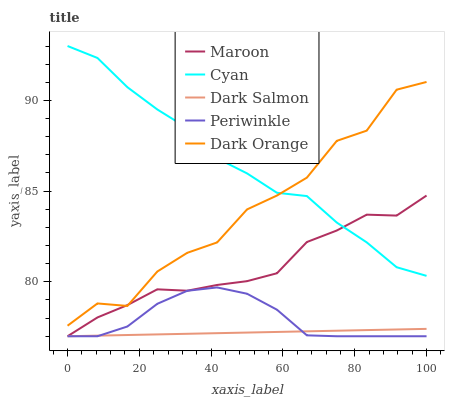Does Dark Salmon have the minimum area under the curve?
Answer yes or no. Yes. Does Cyan have the maximum area under the curve?
Answer yes or no. Yes. Does Periwinkle have the minimum area under the curve?
Answer yes or no. No. Does Periwinkle have the maximum area under the curve?
Answer yes or no. No. Is Dark Salmon the smoothest?
Answer yes or no. Yes. Is Dark Orange the roughest?
Answer yes or no. Yes. Is Periwinkle the smoothest?
Answer yes or no. No. Is Periwinkle the roughest?
Answer yes or no. No. Does Periwinkle have the lowest value?
Answer yes or no. Yes. Does Dark Orange have the lowest value?
Answer yes or no. No. Does Cyan have the highest value?
Answer yes or no. Yes. Does Periwinkle have the highest value?
Answer yes or no. No. Is Dark Salmon less than Cyan?
Answer yes or no. Yes. Is Cyan greater than Dark Salmon?
Answer yes or no. Yes. Does Dark Orange intersect Cyan?
Answer yes or no. Yes. Is Dark Orange less than Cyan?
Answer yes or no. No. Is Dark Orange greater than Cyan?
Answer yes or no. No. Does Dark Salmon intersect Cyan?
Answer yes or no. No. 